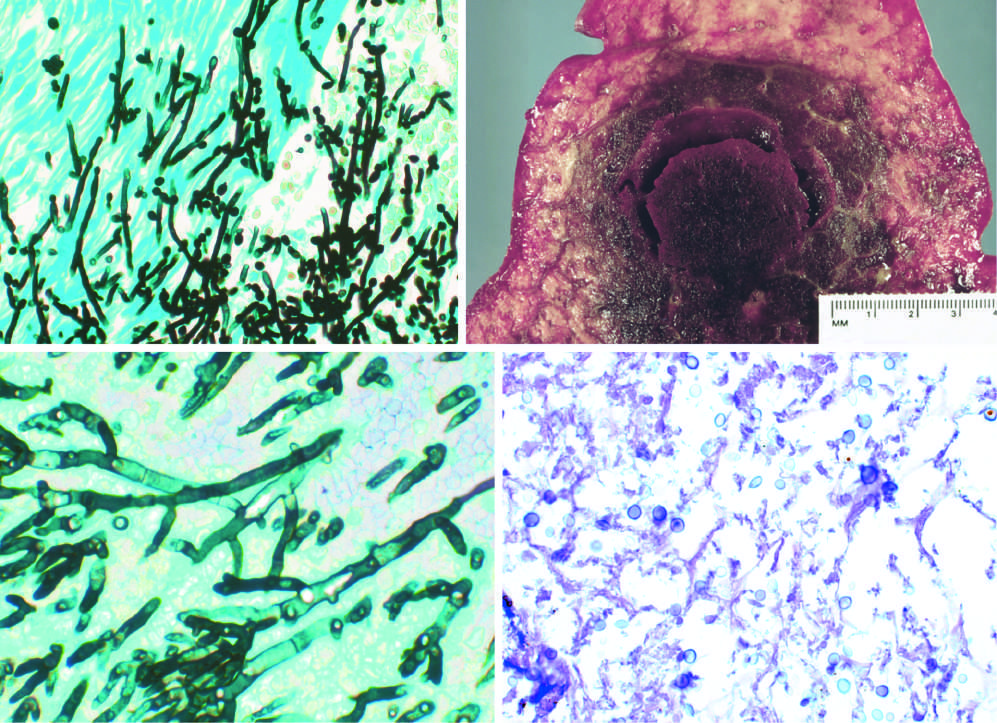how are the organisms?
Answer the question using a single word or phrase. Somewhat variable in size 